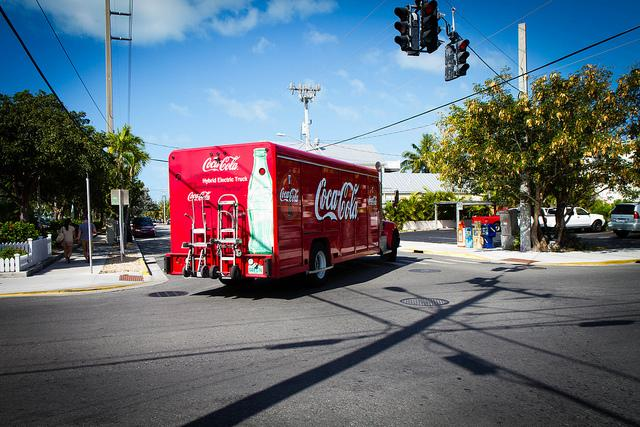Where is the truck going? store 